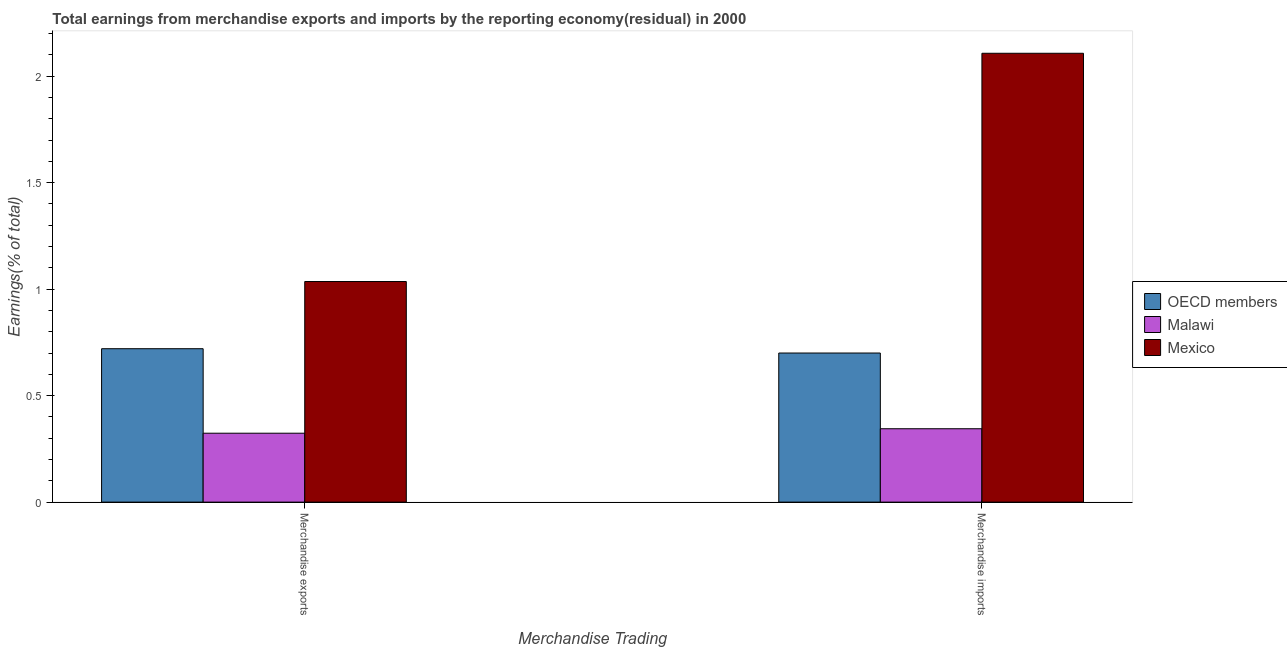How many groups of bars are there?
Ensure brevity in your answer.  2. Are the number of bars on each tick of the X-axis equal?
Your answer should be compact. Yes. How many bars are there on the 1st tick from the right?
Your answer should be compact. 3. What is the label of the 1st group of bars from the left?
Give a very brief answer. Merchandise exports. What is the earnings from merchandise imports in Mexico?
Offer a very short reply. 2.11. Across all countries, what is the maximum earnings from merchandise imports?
Your response must be concise. 2.11. Across all countries, what is the minimum earnings from merchandise imports?
Your answer should be very brief. 0.34. In which country was the earnings from merchandise imports minimum?
Your answer should be compact. Malawi. What is the total earnings from merchandise imports in the graph?
Your response must be concise. 3.15. What is the difference between the earnings from merchandise imports in OECD members and that in Malawi?
Provide a succinct answer. 0.36. What is the difference between the earnings from merchandise imports in Malawi and the earnings from merchandise exports in Mexico?
Keep it short and to the point. -0.69. What is the average earnings from merchandise imports per country?
Provide a succinct answer. 1.05. What is the difference between the earnings from merchandise exports and earnings from merchandise imports in Malawi?
Your answer should be compact. -0.02. In how many countries, is the earnings from merchandise exports greater than 0.2 %?
Give a very brief answer. 3. What is the ratio of the earnings from merchandise imports in Malawi to that in OECD members?
Your answer should be compact. 0.49. Is the earnings from merchandise imports in Mexico less than that in Malawi?
Give a very brief answer. No. In how many countries, is the earnings from merchandise imports greater than the average earnings from merchandise imports taken over all countries?
Ensure brevity in your answer.  1. What does the 2nd bar from the left in Merchandise exports represents?
Offer a terse response. Malawi. What does the 1st bar from the right in Merchandise imports represents?
Offer a terse response. Mexico. How many countries are there in the graph?
Keep it short and to the point. 3. What is the difference between two consecutive major ticks on the Y-axis?
Provide a short and direct response. 0.5. Does the graph contain any zero values?
Provide a succinct answer. No. Does the graph contain grids?
Your response must be concise. No. Where does the legend appear in the graph?
Give a very brief answer. Center right. What is the title of the graph?
Your answer should be very brief. Total earnings from merchandise exports and imports by the reporting economy(residual) in 2000. Does "High income: nonOECD" appear as one of the legend labels in the graph?
Make the answer very short. No. What is the label or title of the X-axis?
Offer a terse response. Merchandise Trading. What is the label or title of the Y-axis?
Give a very brief answer. Earnings(% of total). What is the Earnings(% of total) in OECD members in Merchandise exports?
Provide a short and direct response. 0.72. What is the Earnings(% of total) of Malawi in Merchandise exports?
Offer a very short reply. 0.32. What is the Earnings(% of total) of Mexico in Merchandise exports?
Provide a succinct answer. 1.04. What is the Earnings(% of total) of OECD members in Merchandise imports?
Give a very brief answer. 0.7. What is the Earnings(% of total) of Malawi in Merchandise imports?
Offer a very short reply. 0.34. What is the Earnings(% of total) in Mexico in Merchandise imports?
Make the answer very short. 2.11. Across all Merchandise Trading, what is the maximum Earnings(% of total) in OECD members?
Offer a very short reply. 0.72. Across all Merchandise Trading, what is the maximum Earnings(% of total) of Malawi?
Your answer should be compact. 0.34. Across all Merchandise Trading, what is the maximum Earnings(% of total) of Mexico?
Make the answer very short. 2.11. Across all Merchandise Trading, what is the minimum Earnings(% of total) of OECD members?
Your answer should be very brief. 0.7. Across all Merchandise Trading, what is the minimum Earnings(% of total) of Malawi?
Ensure brevity in your answer.  0.32. Across all Merchandise Trading, what is the minimum Earnings(% of total) of Mexico?
Your answer should be very brief. 1.04. What is the total Earnings(% of total) in OECD members in the graph?
Your answer should be compact. 1.42. What is the total Earnings(% of total) of Malawi in the graph?
Your answer should be very brief. 0.67. What is the total Earnings(% of total) in Mexico in the graph?
Offer a terse response. 3.14. What is the difference between the Earnings(% of total) of OECD members in Merchandise exports and that in Merchandise imports?
Ensure brevity in your answer.  0.02. What is the difference between the Earnings(% of total) in Malawi in Merchandise exports and that in Merchandise imports?
Your answer should be very brief. -0.02. What is the difference between the Earnings(% of total) in Mexico in Merchandise exports and that in Merchandise imports?
Provide a succinct answer. -1.07. What is the difference between the Earnings(% of total) in OECD members in Merchandise exports and the Earnings(% of total) in Malawi in Merchandise imports?
Offer a very short reply. 0.38. What is the difference between the Earnings(% of total) in OECD members in Merchandise exports and the Earnings(% of total) in Mexico in Merchandise imports?
Give a very brief answer. -1.39. What is the difference between the Earnings(% of total) in Malawi in Merchandise exports and the Earnings(% of total) in Mexico in Merchandise imports?
Keep it short and to the point. -1.78. What is the average Earnings(% of total) of OECD members per Merchandise Trading?
Give a very brief answer. 0.71. What is the average Earnings(% of total) in Malawi per Merchandise Trading?
Provide a succinct answer. 0.33. What is the average Earnings(% of total) in Mexico per Merchandise Trading?
Make the answer very short. 1.57. What is the difference between the Earnings(% of total) in OECD members and Earnings(% of total) in Malawi in Merchandise exports?
Provide a succinct answer. 0.4. What is the difference between the Earnings(% of total) of OECD members and Earnings(% of total) of Mexico in Merchandise exports?
Ensure brevity in your answer.  -0.32. What is the difference between the Earnings(% of total) of Malawi and Earnings(% of total) of Mexico in Merchandise exports?
Your response must be concise. -0.71. What is the difference between the Earnings(% of total) in OECD members and Earnings(% of total) in Malawi in Merchandise imports?
Keep it short and to the point. 0.36. What is the difference between the Earnings(% of total) in OECD members and Earnings(% of total) in Mexico in Merchandise imports?
Keep it short and to the point. -1.41. What is the difference between the Earnings(% of total) in Malawi and Earnings(% of total) in Mexico in Merchandise imports?
Your response must be concise. -1.76. What is the ratio of the Earnings(% of total) of OECD members in Merchandise exports to that in Merchandise imports?
Your response must be concise. 1.03. What is the ratio of the Earnings(% of total) of Malawi in Merchandise exports to that in Merchandise imports?
Provide a short and direct response. 0.94. What is the ratio of the Earnings(% of total) in Mexico in Merchandise exports to that in Merchandise imports?
Provide a short and direct response. 0.49. What is the difference between the highest and the second highest Earnings(% of total) of OECD members?
Your answer should be very brief. 0.02. What is the difference between the highest and the second highest Earnings(% of total) of Malawi?
Provide a short and direct response. 0.02. What is the difference between the highest and the second highest Earnings(% of total) in Mexico?
Your answer should be very brief. 1.07. What is the difference between the highest and the lowest Earnings(% of total) of OECD members?
Offer a terse response. 0.02. What is the difference between the highest and the lowest Earnings(% of total) of Malawi?
Provide a short and direct response. 0.02. What is the difference between the highest and the lowest Earnings(% of total) of Mexico?
Make the answer very short. 1.07. 